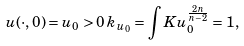<formula> <loc_0><loc_0><loc_500><loc_500>u ( \cdot , 0 ) = u _ { 0 } > 0 \, k _ { u _ { 0 } } = \int K u _ { 0 } ^ { \frac { 2 n } { n - 2 } } = 1 ,</formula> 